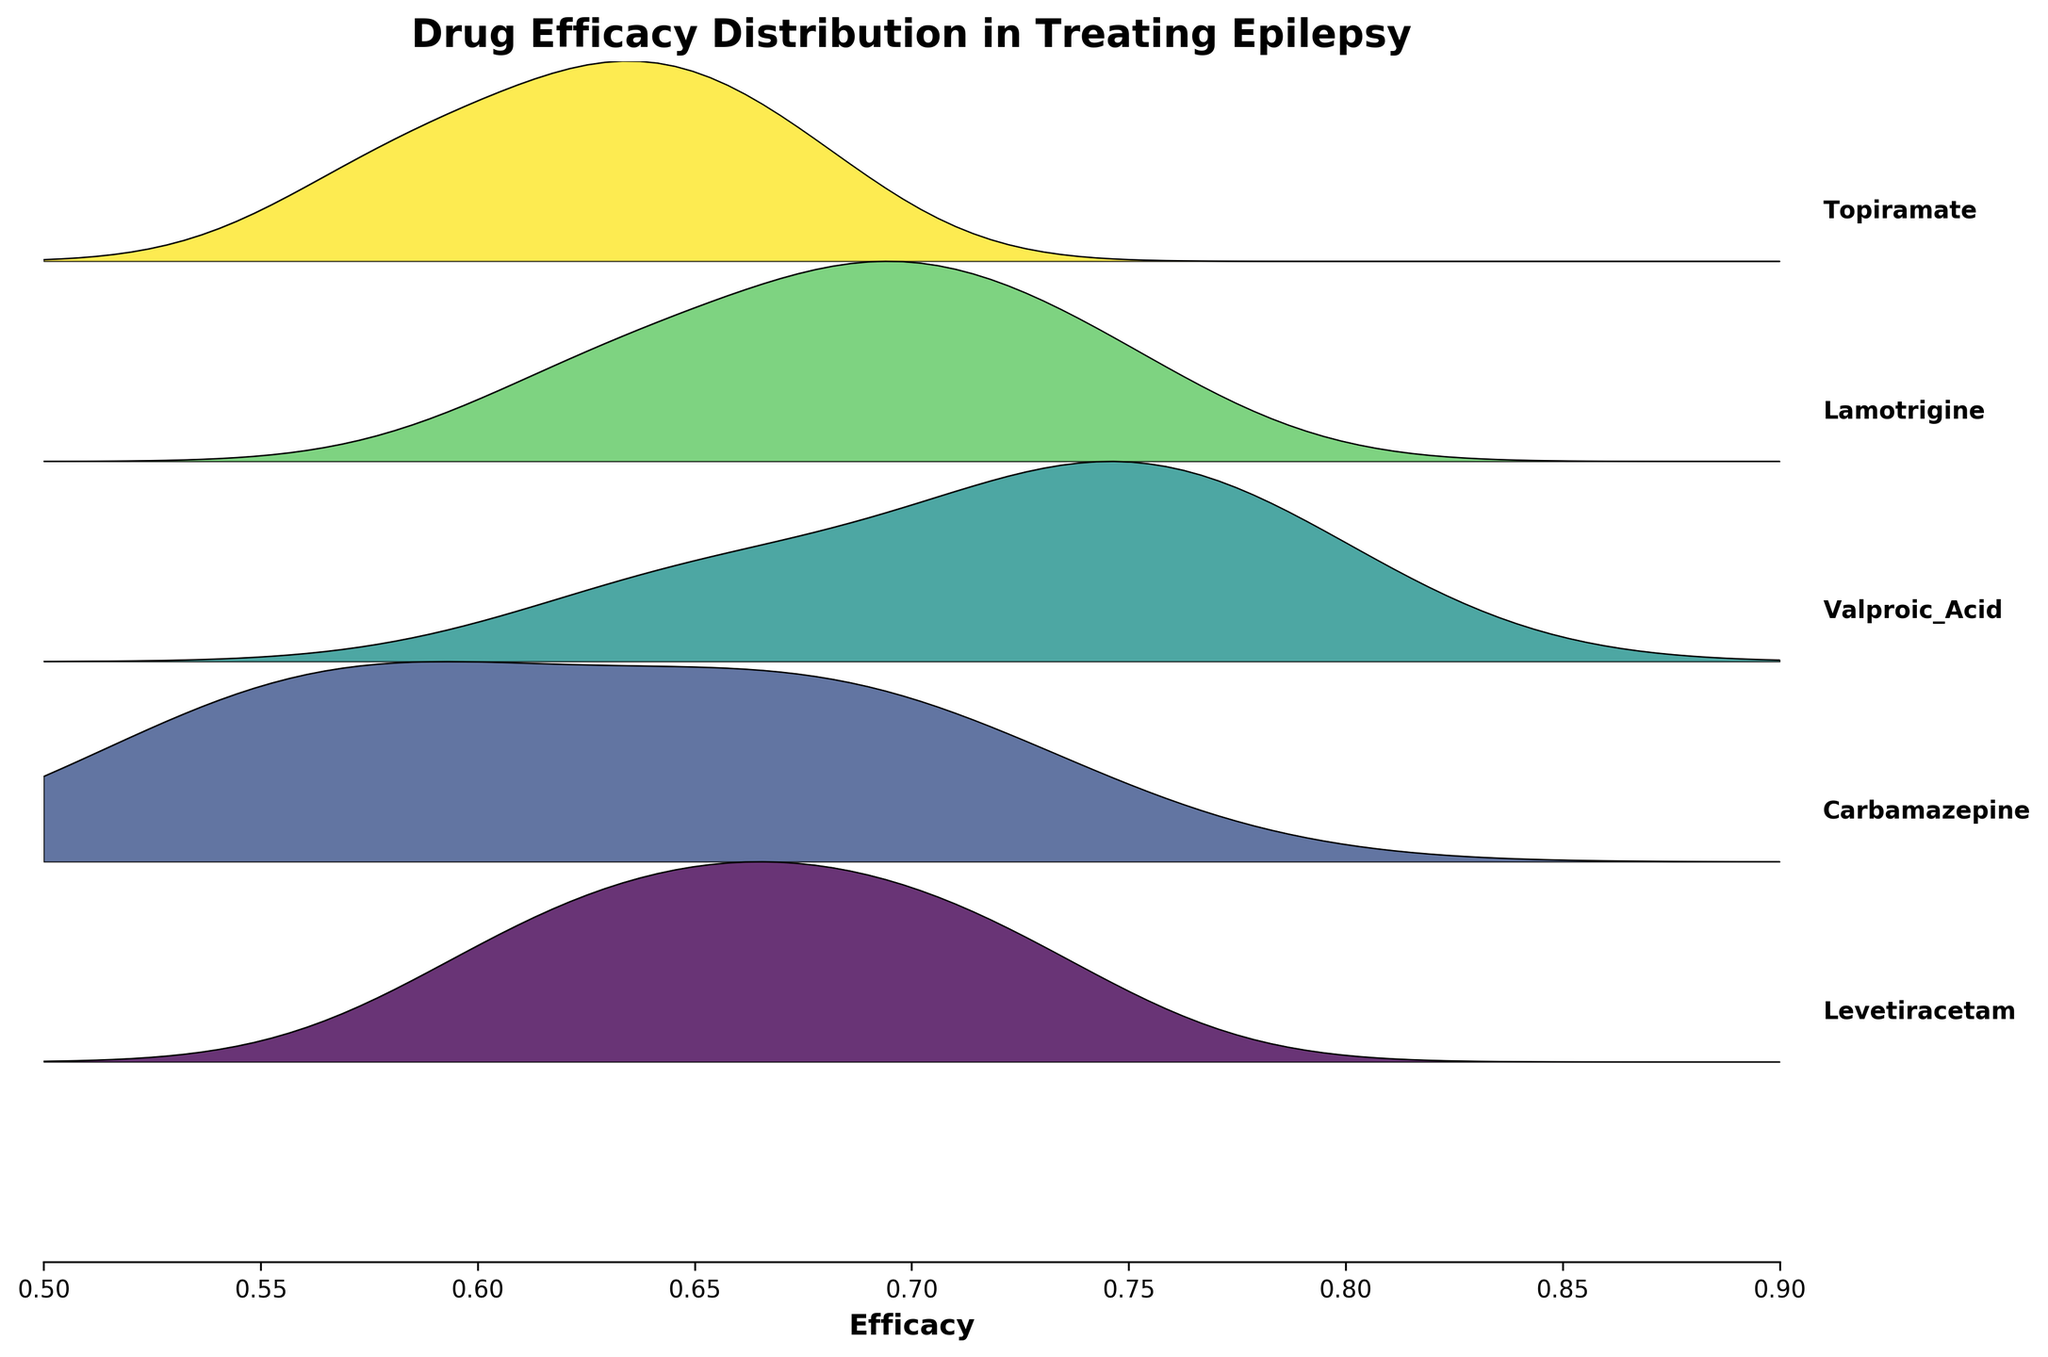what's the title of the figure? The title of the figure is mentioned at the top of the plot.
Answer: Drug Efficacy Distribution in Treating Epilepsy How many drugs are compared in the plot? Each drug is represented by a different color band in the plot. Count the number of unique bands.
Answer: 5 What is the range of efficacy values shown in the plot? The x-axis shows the range of efficacy values. Observe the limits at the start and end of the axis.
Answer: 0.5 to 0.9 Which drug appears to have the highest peak in efficacy distribution? Identify the drug with the highest peak in its respective layer, which indicates the highest density of efficacy values.
Answer: Valproic Acid Compare the efficacy distributions of Levetiracetam and Topiramate. Which one generally has higher efficacy? Compare the positions and heights of the distribution peaks for both drugs.
Answer: Levetiracetam What does the y-axis represent in this plot? Since there are no specific numerical labels on the y-axis, it represents the different drugs being compared.
Answer: Different drugs Identify the drug with the least spread in efficacy distribution. Why do you think this is the case? Look for the drug whose efficacy distribution appears narrowest, indicating less variability in efficacy values.
Answer: Valproic Acid Compare the efficacy of Carbamazepine and Levetiracetam for the age range 19-40. The ages and corresponding efficacy for each drug are shown; compare those specific values for the two drugs.
Answer: Levetiracetam Which seizure type appears to have the highest overall efficacy across all drugs? Consider the efficacy values for each drug and seizure type combination, and determine which type consistently has higher values.
Answer: Generalized What is the efficacy value for Lamotrigine in the age range of 60+? Use the effectiveness values given for Lamotrigine and identify the one corresponding to the age range 60+.
Answer: 0.63 